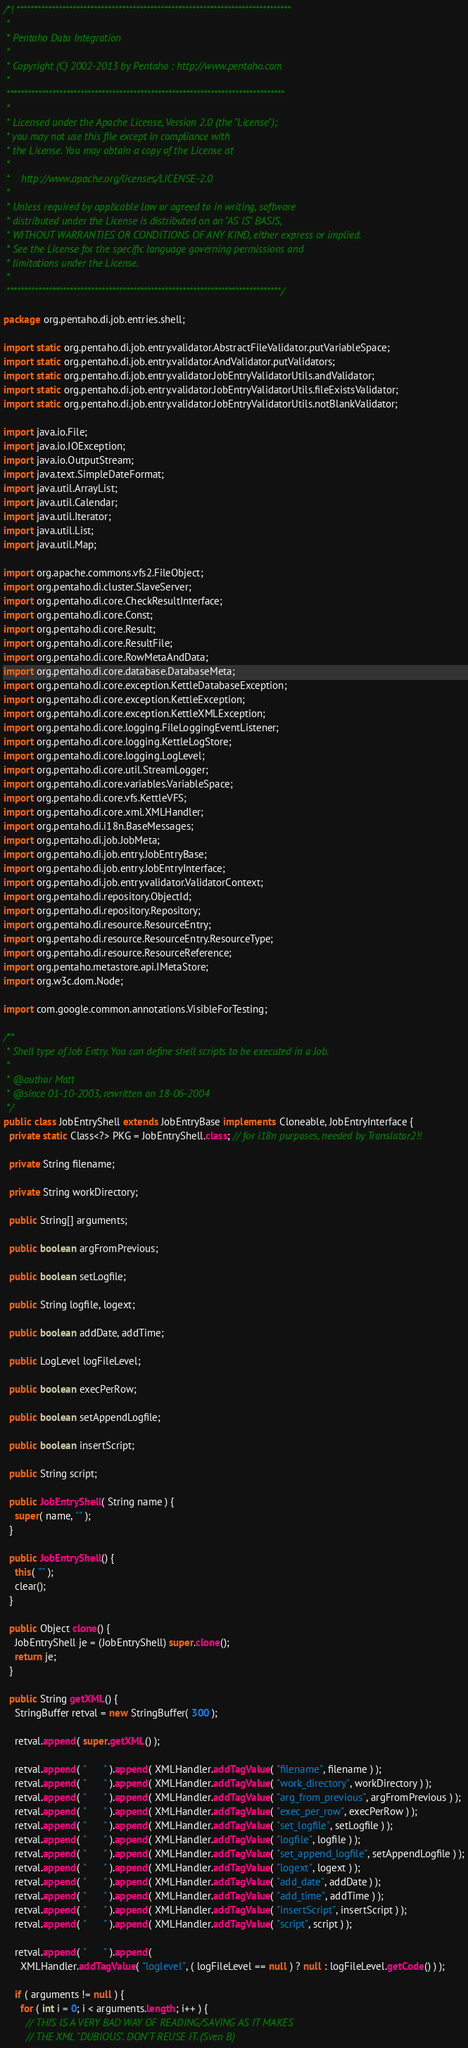<code> <loc_0><loc_0><loc_500><loc_500><_Java_>/*! ******************************************************************************
 *
 * Pentaho Data Integration
 *
 * Copyright (C) 2002-2013 by Pentaho : http://www.pentaho.com
 *
 *******************************************************************************
 *
 * Licensed under the Apache License, Version 2.0 (the "License");
 * you may not use this file except in compliance with
 * the License. You may obtain a copy of the License at
 *
 *    http://www.apache.org/licenses/LICENSE-2.0
 *
 * Unless required by applicable law or agreed to in writing, software
 * distributed under the License is distributed on an "AS IS" BASIS,
 * WITHOUT WARRANTIES OR CONDITIONS OF ANY KIND, either express or implied.
 * See the License for the specific language governing permissions and
 * limitations under the License.
 *
 ******************************************************************************/

package org.pentaho.di.job.entries.shell;

import static org.pentaho.di.job.entry.validator.AbstractFileValidator.putVariableSpace;
import static org.pentaho.di.job.entry.validator.AndValidator.putValidators;
import static org.pentaho.di.job.entry.validator.JobEntryValidatorUtils.andValidator;
import static org.pentaho.di.job.entry.validator.JobEntryValidatorUtils.fileExistsValidator;
import static org.pentaho.di.job.entry.validator.JobEntryValidatorUtils.notBlankValidator;

import java.io.File;
import java.io.IOException;
import java.io.OutputStream;
import java.text.SimpleDateFormat;
import java.util.ArrayList;
import java.util.Calendar;
import java.util.Iterator;
import java.util.List;
import java.util.Map;

import org.apache.commons.vfs2.FileObject;
import org.pentaho.di.cluster.SlaveServer;
import org.pentaho.di.core.CheckResultInterface;
import org.pentaho.di.core.Const;
import org.pentaho.di.core.Result;
import org.pentaho.di.core.ResultFile;
import org.pentaho.di.core.RowMetaAndData;
import org.pentaho.di.core.database.DatabaseMeta;
import org.pentaho.di.core.exception.KettleDatabaseException;
import org.pentaho.di.core.exception.KettleException;
import org.pentaho.di.core.exception.KettleXMLException;
import org.pentaho.di.core.logging.FileLoggingEventListener;
import org.pentaho.di.core.logging.KettleLogStore;
import org.pentaho.di.core.logging.LogLevel;
import org.pentaho.di.core.util.StreamLogger;
import org.pentaho.di.core.variables.VariableSpace;
import org.pentaho.di.core.vfs.KettleVFS;
import org.pentaho.di.core.xml.XMLHandler;
import org.pentaho.di.i18n.BaseMessages;
import org.pentaho.di.job.JobMeta;
import org.pentaho.di.job.entry.JobEntryBase;
import org.pentaho.di.job.entry.JobEntryInterface;
import org.pentaho.di.job.entry.validator.ValidatorContext;
import org.pentaho.di.repository.ObjectId;
import org.pentaho.di.repository.Repository;
import org.pentaho.di.resource.ResourceEntry;
import org.pentaho.di.resource.ResourceEntry.ResourceType;
import org.pentaho.di.resource.ResourceReference;
import org.pentaho.metastore.api.IMetaStore;
import org.w3c.dom.Node;

import com.google.common.annotations.VisibleForTesting;

/**
 * Shell type of Job Entry. You can define shell scripts to be executed in a Job.
 *
 * @author Matt
 * @since 01-10-2003, rewritten on 18-06-2004
 */
public class JobEntryShell extends JobEntryBase implements Cloneable, JobEntryInterface {
  private static Class<?> PKG = JobEntryShell.class; // for i18n purposes, needed by Translator2!!

  private String filename;

  private String workDirectory;

  public String[] arguments;

  public boolean argFromPrevious;

  public boolean setLogfile;

  public String logfile, logext;

  public boolean addDate, addTime;

  public LogLevel logFileLevel;

  public boolean execPerRow;

  public boolean setAppendLogfile;

  public boolean insertScript;

  public String script;

  public JobEntryShell( String name ) {
    super( name, "" );
  }

  public JobEntryShell() {
    this( "" );
    clear();
  }

  public Object clone() {
    JobEntryShell je = (JobEntryShell) super.clone();
    return je;
  }

  public String getXML() {
    StringBuffer retval = new StringBuffer( 300 );

    retval.append( super.getXML() );

    retval.append( "      " ).append( XMLHandler.addTagValue( "filename", filename ) );
    retval.append( "      " ).append( XMLHandler.addTagValue( "work_directory", workDirectory ) );
    retval.append( "      " ).append( XMLHandler.addTagValue( "arg_from_previous", argFromPrevious ) );
    retval.append( "      " ).append( XMLHandler.addTagValue( "exec_per_row", execPerRow ) );
    retval.append( "      " ).append( XMLHandler.addTagValue( "set_logfile", setLogfile ) );
    retval.append( "      " ).append( XMLHandler.addTagValue( "logfile", logfile ) );
    retval.append( "      " ).append( XMLHandler.addTagValue( "set_append_logfile", setAppendLogfile ) );
    retval.append( "      " ).append( XMLHandler.addTagValue( "logext", logext ) );
    retval.append( "      " ).append( XMLHandler.addTagValue( "add_date", addDate ) );
    retval.append( "      " ).append( XMLHandler.addTagValue( "add_time", addTime ) );
    retval.append( "      " ).append( XMLHandler.addTagValue( "insertScript", insertScript ) );
    retval.append( "      " ).append( XMLHandler.addTagValue( "script", script ) );

    retval.append( "      " ).append(
      XMLHandler.addTagValue( "loglevel", ( logFileLevel == null ) ? null : logFileLevel.getCode() ) );

    if ( arguments != null ) {
      for ( int i = 0; i < arguments.length; i++ ) {
        // THIS IS A VERY BAD WAY OF READING/SAVING AS IT MAKES
        // THE XML "DUBIOUS". DON'T REUSE IT. (Sven B)</code> 